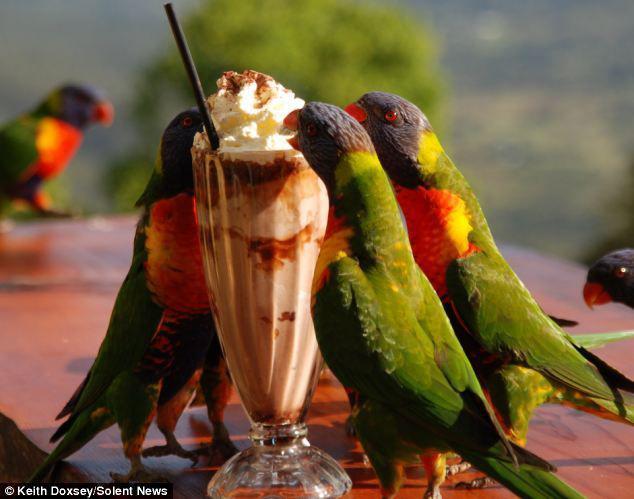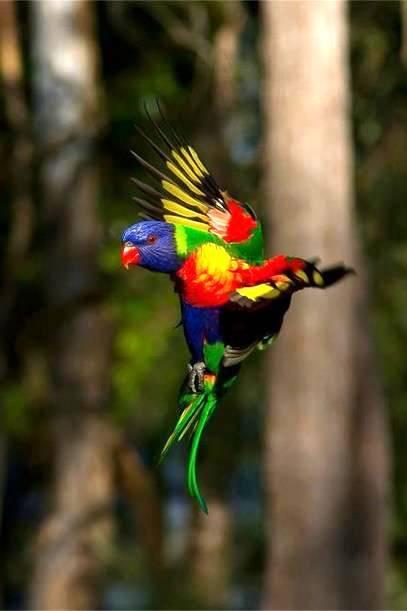The first image is the image on the left, the second image is the image on the right. Given the left and right images, does the statement "Right image contains exactly one parrot." hold true? Answer yes or no. Yes. The first image is the image on the left, the second image is the image on the right. For the images displayed, is the sentence "There are no more than four birds" factually correct? Answer yes or no. No. 